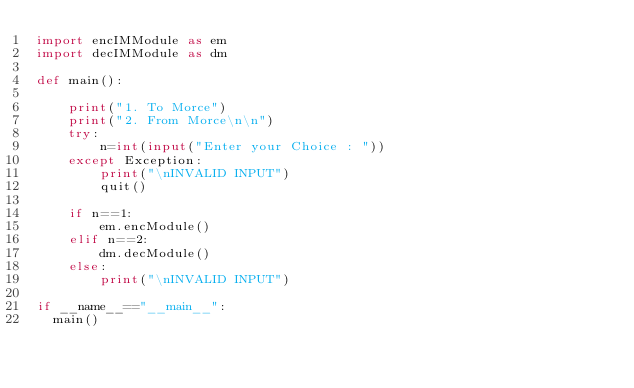<code> <loc_0><loc_0><loc_500><loc_500><_Python_>import encIMModule as em
import decIMModule as dm

def main():
    
    print("1. To Morce")
    print("2. From Morce\n\n")
    try:
        n=int(input("Enter your Choice : "))
    except Exception:
        print("\nINVALID INPUT")
        quit()
    
    if n==1:
        em.encModule()
    elif n==2:
        dm.decModule()
    else:
        print("\nINVALID INPUT")

if __name__=="__main__":
	main()</code> 